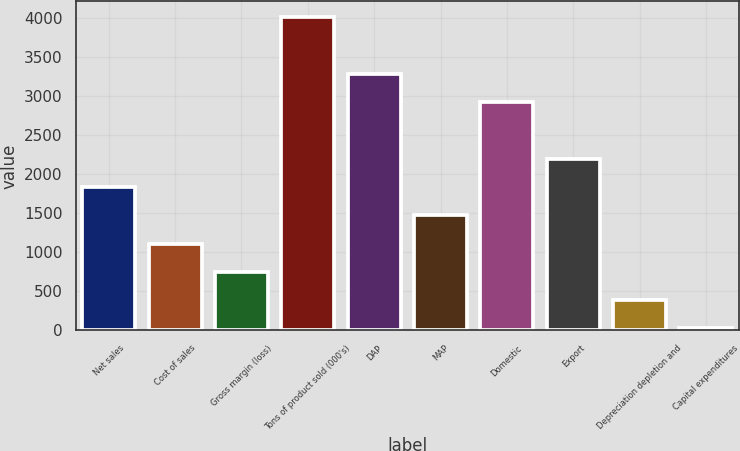Convert chart. <chart><loc_0><loc_0><loc_500><loc_500><bar_chart><fcel>Net sales<fcel>Cost of sales<fcel>Gross margin (loss)<fcel>Tons of product sold (000's)<fcel>DAP<fcel>MAP<fcel>Domestic<fcel>Export<fcel>Depreciation depletion and<fcel>Capital expenditures<nl><fcel>1836.3<fcel>1112.02<fcel>749.88<fcel>4009.14<fcel>3284.86<fcel>1474.16<fcel>2922.72<fcel>2198.44<fcel>387.74<fcel>25.6<nl></chart> 